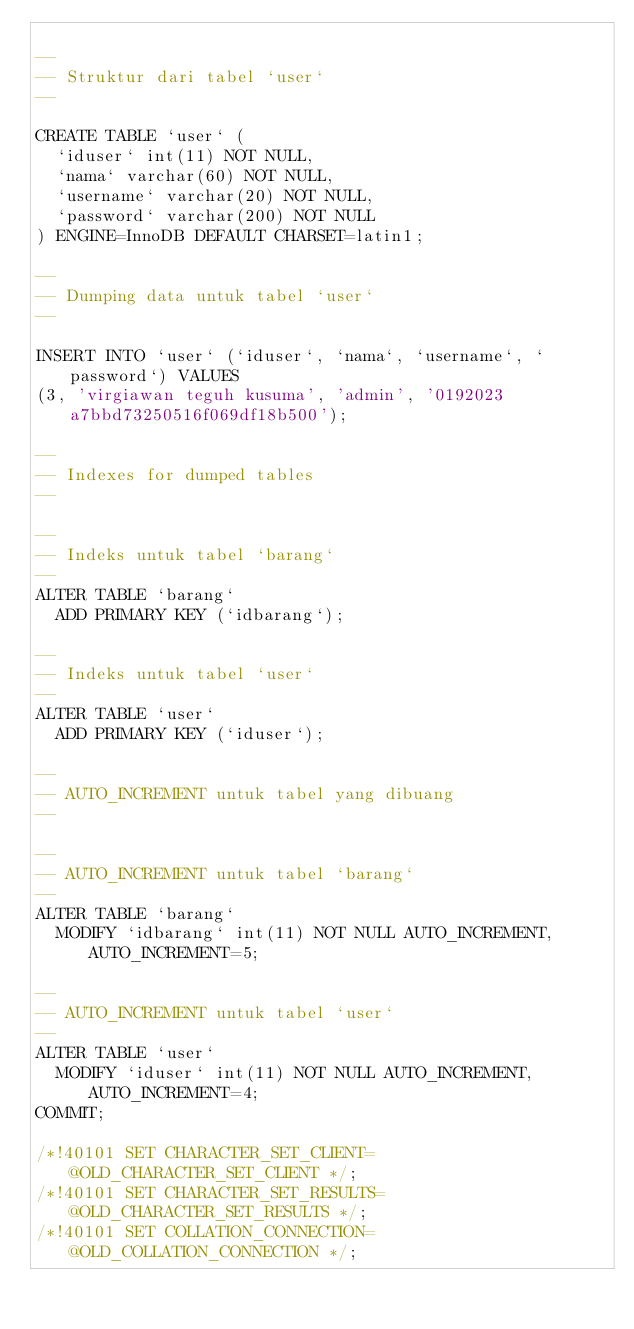<code> <loc_0><loc_0><loc_500><loc_500><_SQL_>
--
-- Struktur dari tabel `user`
--

CREATE TABLE `user` (
  `iduser` int(11) NOT NULL,
  `nama` varchar(60) NOT NULL,
  `username` varchar(20) NOT NULL,
  `password` varchar(200) NOT NULL
) ENGINE=InnoDB DEFAULT CHARSET=latin1;

--
-- Dumping data untuk tabel `user`
--

INSERT INTO `user` (`iduser`, `nama`, `username`, `password`) VALUES
(3, 'virgiawan teguh kusuma', 'admin', '0192023a7bbd73250516f069df18b500');

--
-- Indexes for dumped tables
--

--
-- Indeks untuk tabel `barang`
--
ALTER TABLE `barang`
  ADD PRIMARY KEY (`idbarang`);

--
-- Indeks untuk tabel `user`
--
ALTER TABLE `user`
  ADD PRIMARY KEY (`iduser`);

--
-- AUTO_INCREMENT untuk tabel yang dibuang
--

--
-- AUTO_INCREMENT untuk tabel `barang`
--
ALTER TABLE `barang`
  MODIFY `idbarang` int(11) NOT NULL AUTO_INCREMENT, AUTO_INCREMENT=5;

--
-- AUTO_INCREMENT untuk tabel `user`
--
ALTER TABLE `user`
  MODIFY `iduser` int(11) NOT NULL AUTO_INCREMENT, AUTO_INCREMENT=4;
COMMIT;

/*!40101 SET CHARACTER_SET_CLIENT=@OLD_CHARACTER_SET_CLIENT */;
/*!40101 SET CHARACTER_SET_RESULTS=@OLD_CHARACTER_SET_RESULTS */;
/*!40101 SET COLLATION_CONNECTION=@OLD_COLLATION_CONNECTION */;
</code> 